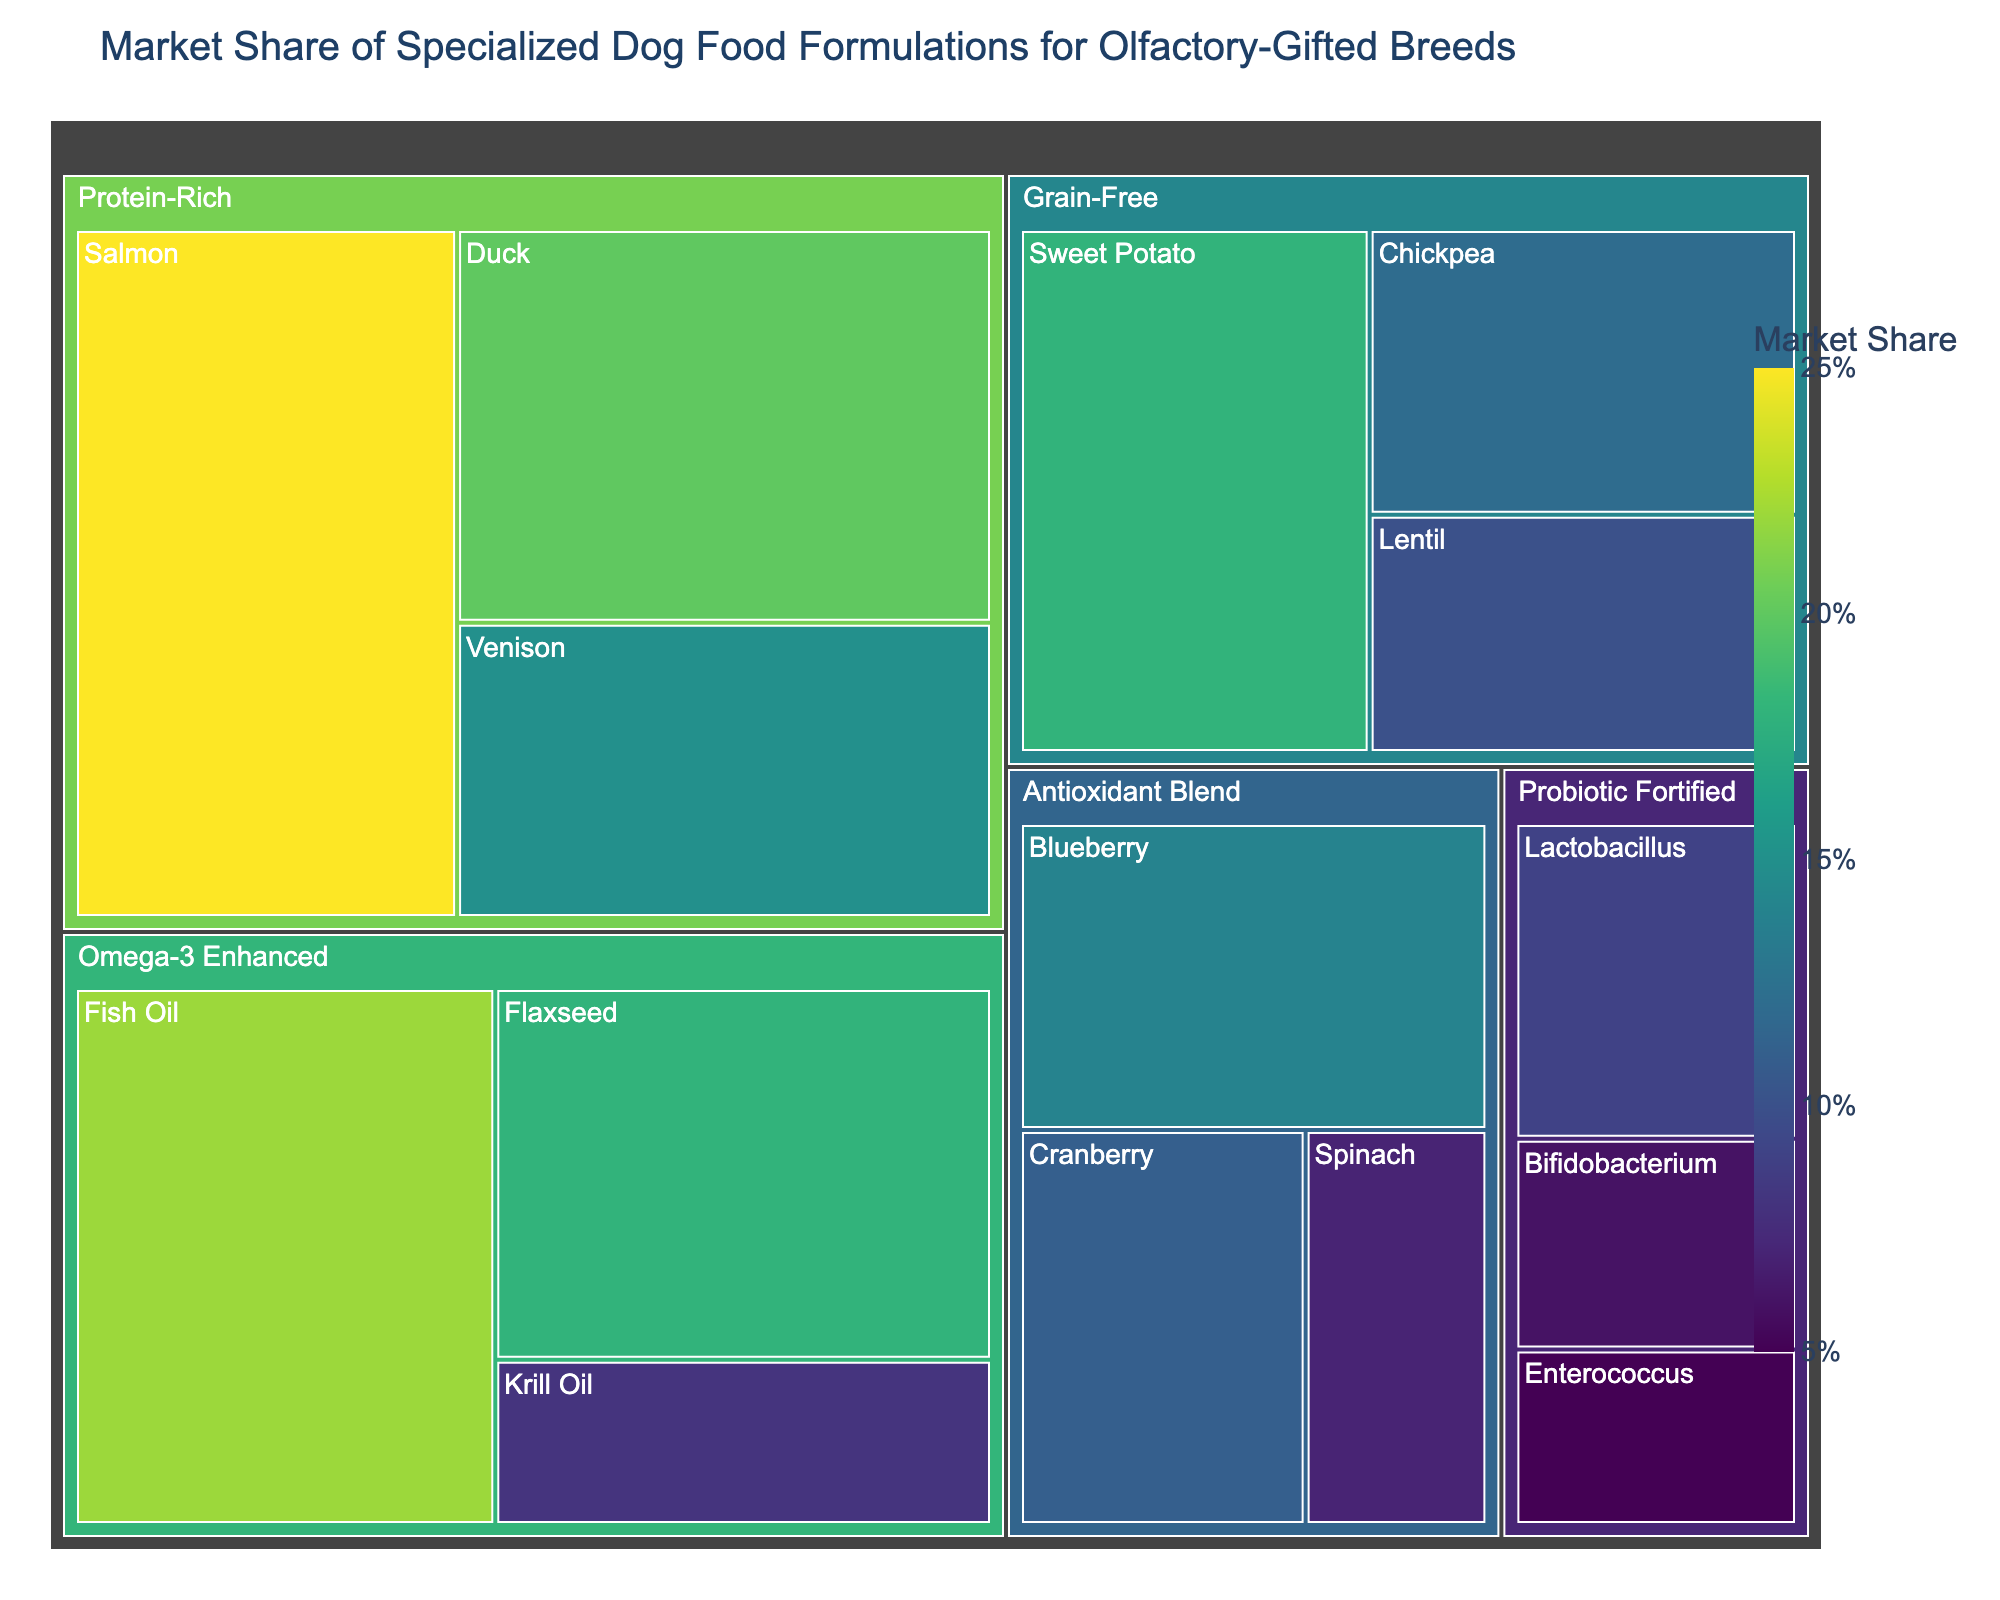what is the title of the figure? The title is usually placed at the top of the figure and provides a brief description of the content or purpose of the visualization. In this case, it mentions the market share and specialized dog food formulations.
Answer: Market Share of Specialized Dog Food Formulations for Olfactory-Gifted Breeds which ingredient has the highest market share in the Protein-Rich category? In the Treemap, the size of the rectangles represents market share. By visually inspecting the rectangles within the Protein-Rich category, the largest subrectangle represents the ingredient with the highest market share.
Answer: Salmon what is the combined market share of the Omega-3 Enhanced category? To find this, sum up the values from the subcategories within the Omega-3 Enhanced category. These values are 22 (Fish Oil), 18 (Flaxseed), and 8 (Krill Oil). 22 + 18 + 8 gives the total market share.
Answer: 48 which ingredient has a higher market share: Sweet Potato or Blueberry? By comparing the sizes of the corresponding rectangles, we can see which one is larger.
Answer: Sweet Potato how does the smallest market share in the Probiotic Fortified category compare to the largest market share in the Antioxidant Blend category? Identify the smallest value in the Probiotic Fortified category (Enterococcus with 5) and the largest value in the Antioxidant Blend category (Blueberry with 14). Compare these two values by subtracting the former from the latter, giving 14 - 5.
Answer: 9 how many categories are represented in the figure? By counting the distinct parent rectangles in the Treemap, which are visually separated and labeled, we can determine the number of categories.
Answer: 5 what is the difference in market share between Flaxseed and Duck? Flaxseed has a market share of 18, and Duck has 20. Subtract the two values to find the difference: 20 - 18.
Answer: 2 what is the average market share for the ingredients in the Grain-Free category? Sum all the values in the Grain-Free category (18 for Sweet Potato, 12 for Chickpea, and 10 for Lentil) and divide by the number of ingredients (3). (18 + 12 + 10) / 3 = 40 / 3.
Answer: Approximately 13.3 which ingredient in the Antioxidant Blend category has the lowest market share? By looking at the size of the rectangles in the Antioxidant Blend category, the smallest one represents the ingredient with the lowest market share.
Answer: Spinach what is the market share of the largest subcategory within the overall plot? Find the largest rectangle by visual inspection, which represents the highest value among all subcategories present in the Treemap.
Answer: Salmon with 25 